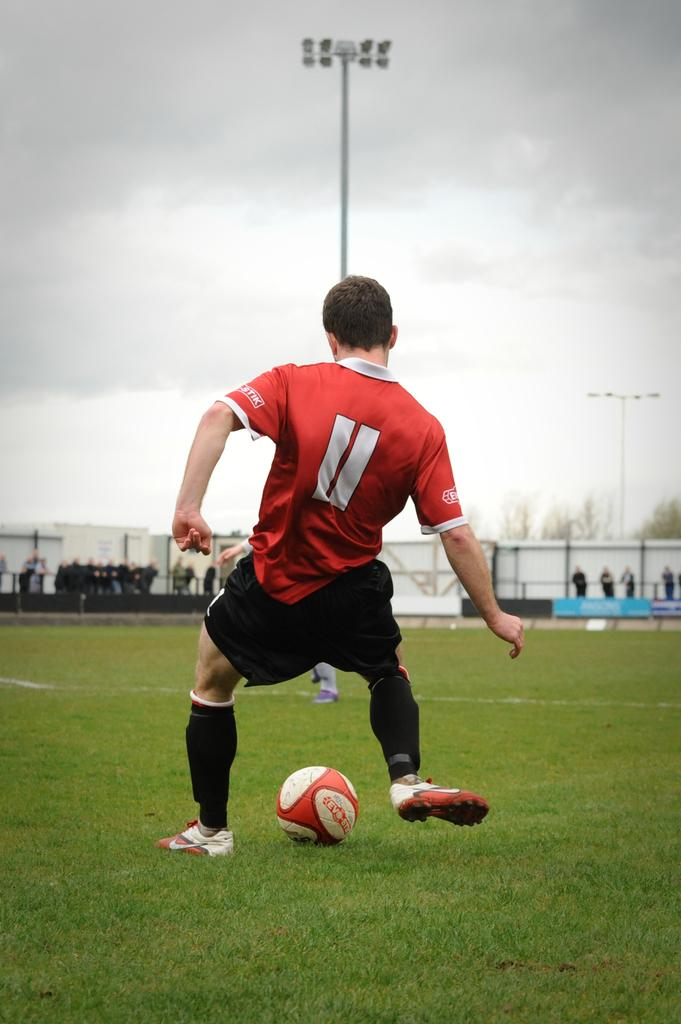<image>
Write a terse but informative summary of the picture. The number 11 is displayed on the shirt of a soccer player. 